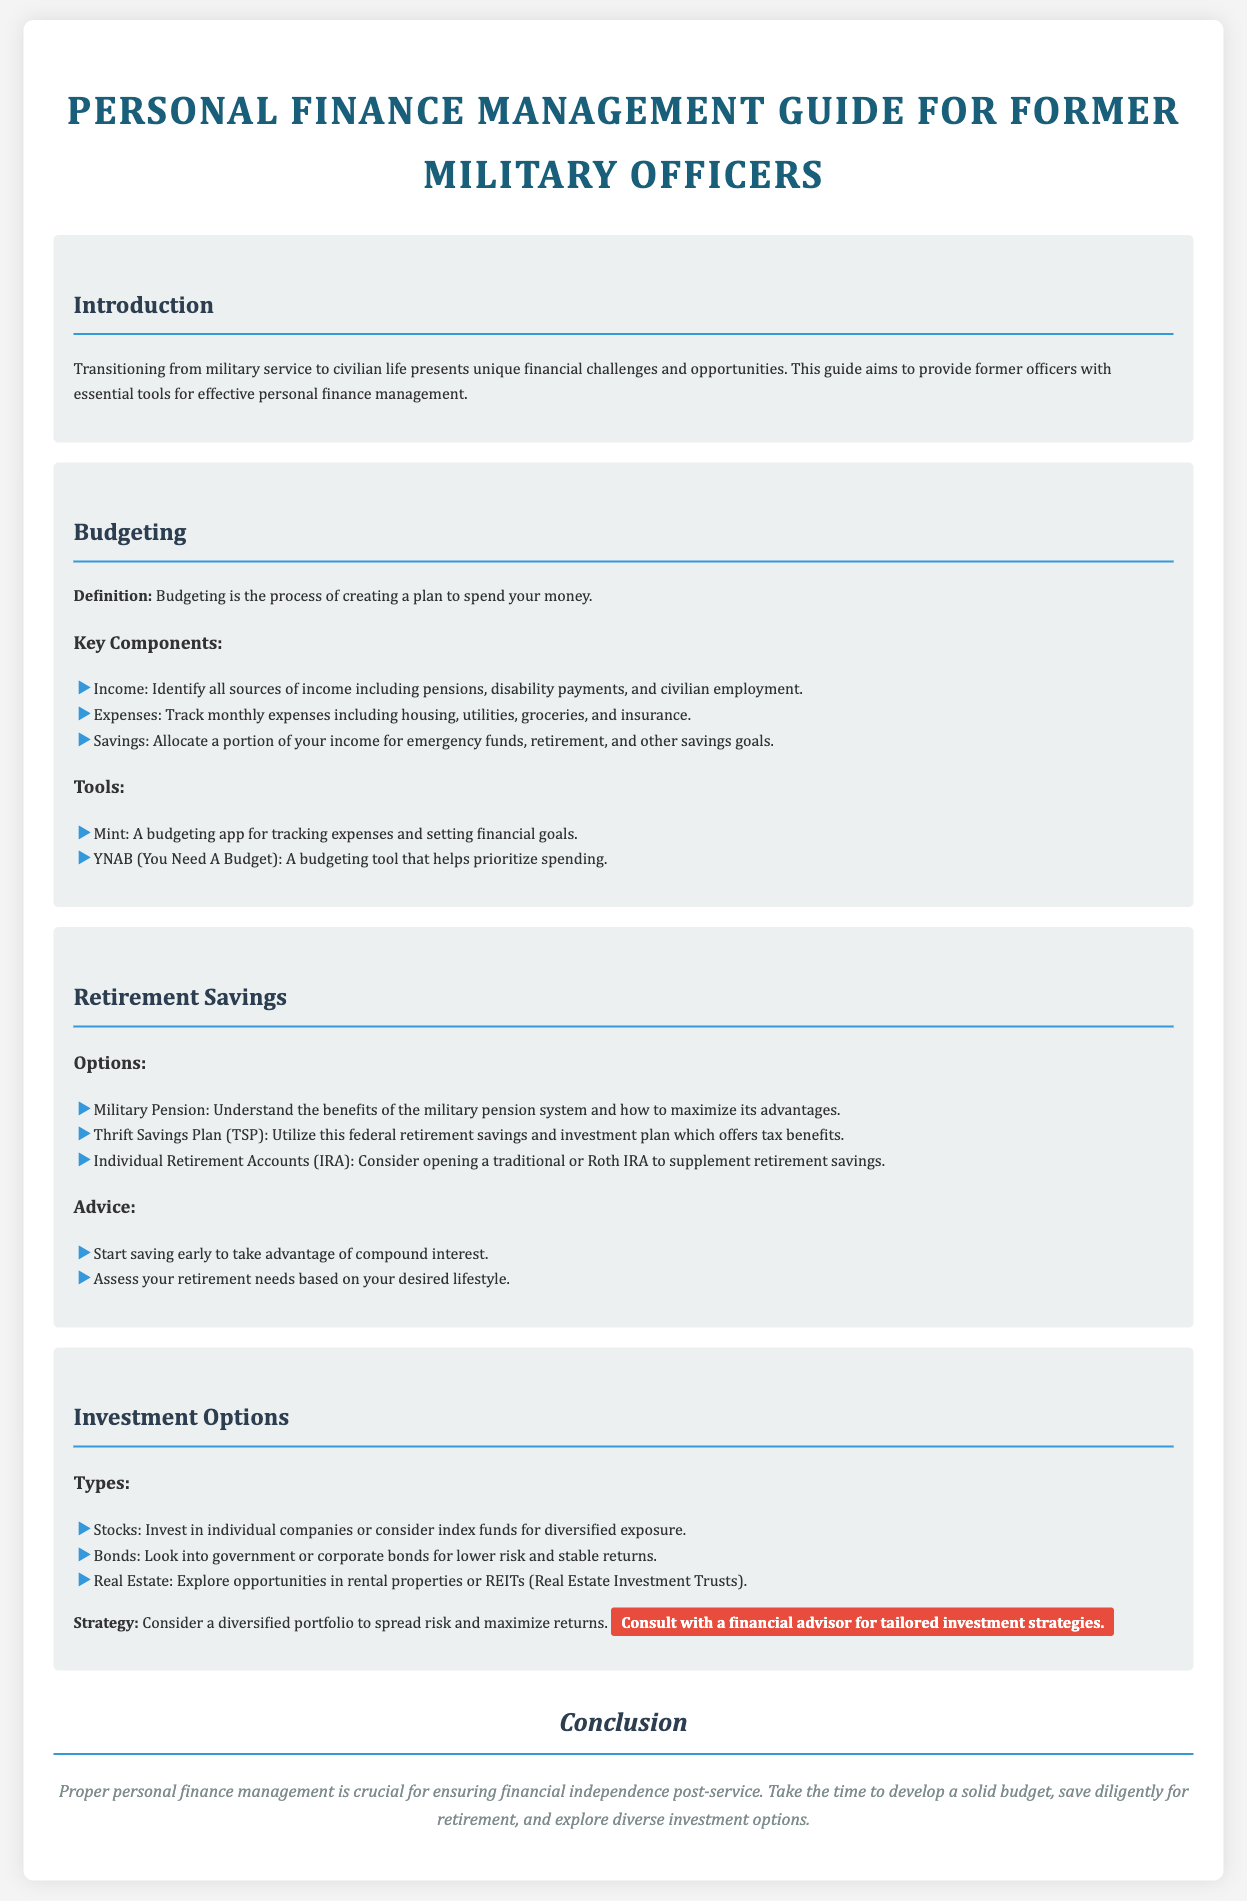What is the primary purpose of this guide? The guide aims to provide former officers with essential tools for effective personal finance management.
Answer: effective personal finance management What budgeting tool helps prioritize spending? YNAB (You Need A Budget) is a budgeting tool that helps prioritize spending according to the document.
Answer: YNAB What savings plan offers tax benefits for federal employees? The document mentions the Thrift Savings Plan (TSP) as a federal retirement savings and investment plan that offers tax benefits.
Answer: Thrift Savings Plan (TSP) What type of accounts can be opened to supplement retirement savings? The document suggests considering opening a traditional or Roth IRA to supplement retirement savings.
Answer: IRA How should former officers assess their retirement needs? According to the document, former officers should assess their retirement needs based on their desired lifestyle.
Answer: desired lifestyle Which investment option is mentioned as having lower risk and stable returns? Government or corporate bonds are mentioned as an investment option for lower risk and stable returns.
Answer: bonds What is a recommended strategy to maximize investment returns? The document advises considering a diversified portfolio to spread risk and maximize returns.
Answer: diversified portfolio What is emphasized as crucial for ensuring financial independence post-service? The document emphasizes that proper personal finance management is crucial for ensuring financial independence post-service.
Answer: proper personal finance management 